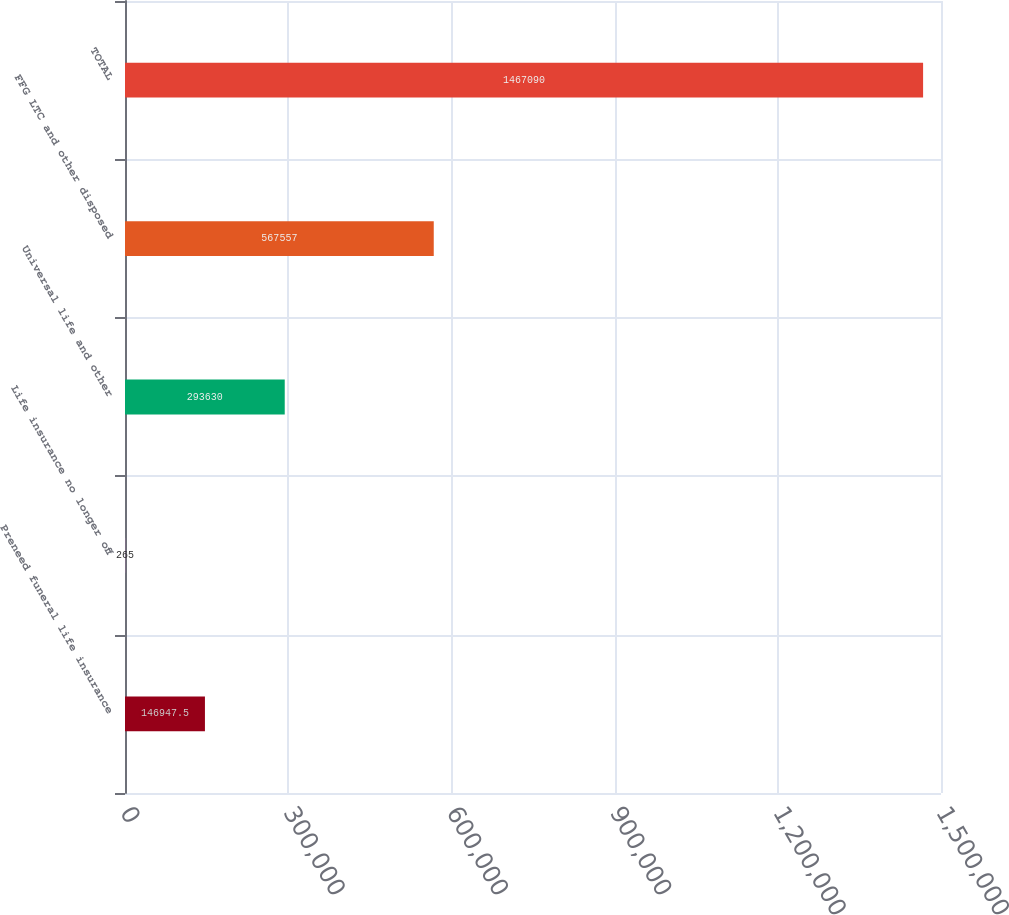Convert chart. <chart><loc_0><loc_0><loc_500><loc_500><bar_chart><fcel>Preneed funeral life insurance<fcel>Life insurance no longer off<fcel>Universal life and other<fcel>FFG LTC and other disposed<fcel>TOTAL<nl><fcel>146948<fcel>265<fcel>293630<fcel>567557<fcel>1.46709e+06<nl></chart> 